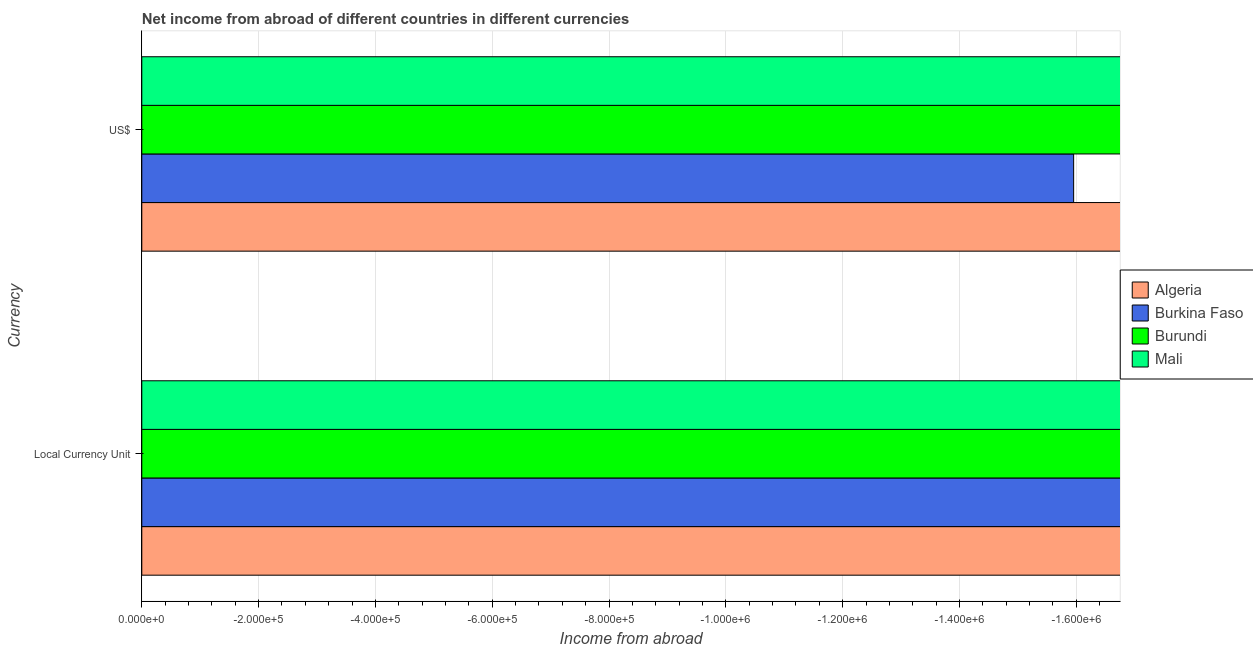How many different coloured bars are there?
Ensure brevity in your answer.  0. Are the number of bars on each tick of the Y-axis equal?
Ensure brevity in your answer.  Yes. How many bars are there on the 1st tick from the top?
Offer a terse response. 0. What is the label of the 1st group of bars from the top?
Keep it short and to the point. US$. Across all countries, what is the minimum income from abroad in constant 2005 us$?
Give a very brief answer. 0. What is the difference between the income from abroad in us$ in Mali and the income from abroad in constant 2005 us$ in Burundi?
Your answer should be compact. 0. What is the average income from abroad in us$ per country?
Give a very brief answer. 0. In how many countries, is the income from abroad in us$ greater than -640000 units?
Provide a succinct answer. 0. In how many countries, is the income from abroad in constant 2005 us$ greater than the average income from abroad in constant 2005 us$ taken over all countries?
Your answer should be very brief. 0. Are all the bars in the graph horizontal?
Provide a succinct answer. Yes. How many countries are there in the graph?
Your response must be concise. 4. Are the values on the major ticks of X-axis written in scientific E-notation?
Your answer should be very brief. Yes. Does the graph contain any zero values?
Keep it short and to the point. Yes. What is the title of the graph?
Give a very brief answer. Net income from abroad of different countries in different currencies. What is the label or title of the X-axis?
Offer a very short reply. Income from abroad. What is the label or title of the Y-axis?
Keep it short and to the point. Currency. What is the Income from abroad in Burkina Faso in US$?
Your answer should be very brief. 0. What is the Income from abroad of Burundi in US$?
Your response must be concise. 0. What is the total Income from abroad in Burkina Faso in the graph?
Your answer should be compact. 0. What is the average Income from abroad in Mali per Currency?
Keep it short and to the point. 0. 